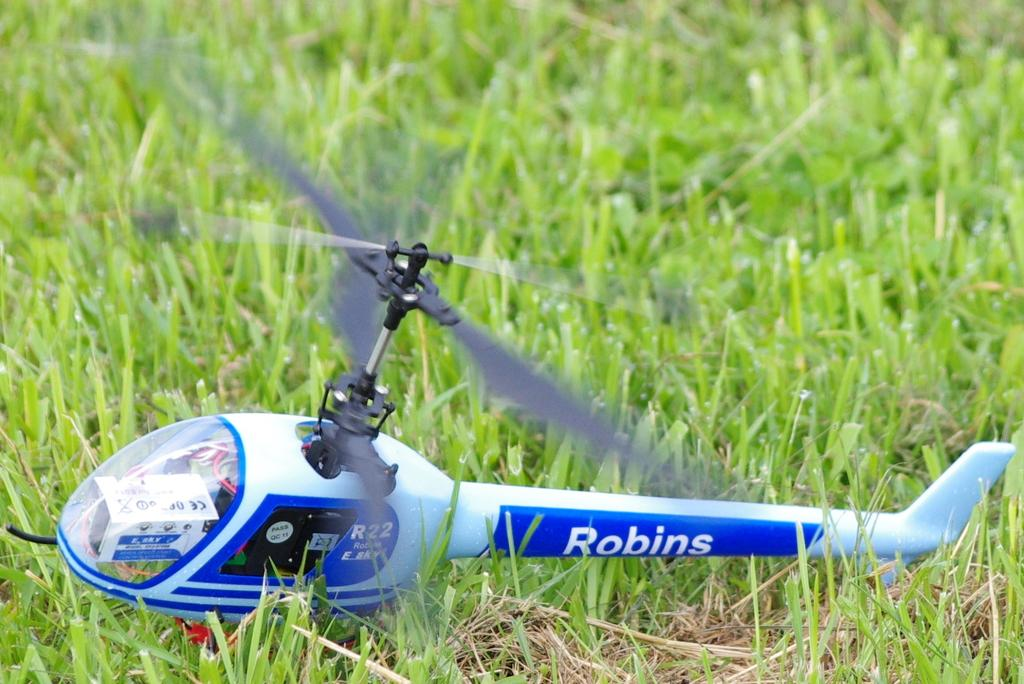What is the main subject of the image? The main subject of the image is a toy helicopter. Where is the toy helicopter located? The toy helicopter is on the grassland. What is the area in the foreground of the image? The grassland is in the foreground area of the image. What word is written on the toy helicopter's shirt in the image? There is no shirt on the toy helicopter in the image, as it is not a living being. 